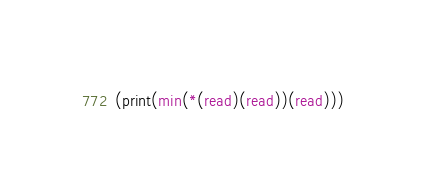<code> <loc_0><loc_0><loc_500><loc_500><_Scheme_>(print(min(*(read)(read))(read)))</code> 